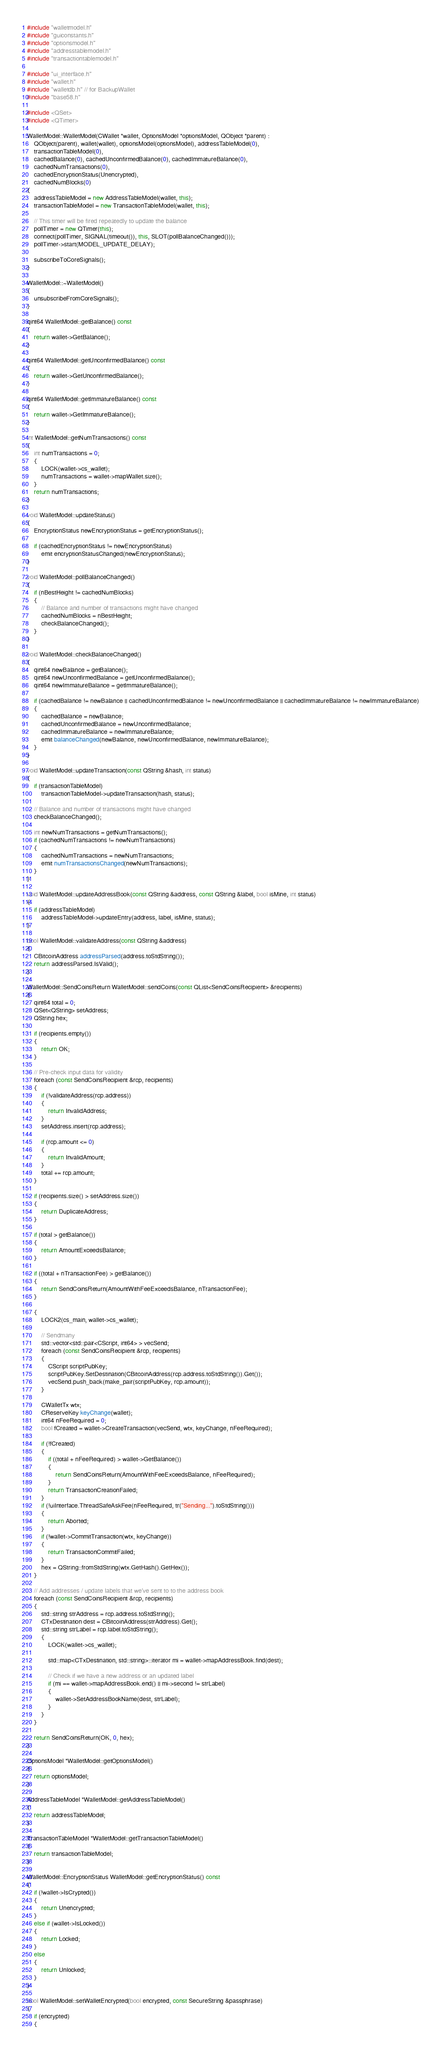Convert code to text. <code><loc_0><loc_0><loc_500><loc_500><_C++_>#include "walletmodel.h"
#include "guiconstants.h"
#include "optionsmodel.h"
#include "addresstablemodel.h"
#include "transactiontablemodel.h"

#include "ui_interface.h"
#include "wallet.h"
#include "walletdb.h" // for BackupWallet
#include "base58.h"

#include <QSet>
#include <QTimer>

WalletModel::WalletModel(CWallet *wallet, OptionsModel *optionsModel, QObject *parent) :
    QObject(parent), wallet(wallet), optionsModel(optionsModel), addressTableModel(0),
    transactionTableModel(0),
    cachedBalance(0), cachedUnconfirmedBalance(0), cachedImmatureBalance(0),
    cachedNumTransactions(0),
    cachedEncryptionStatus(Unencrypted),
    cachedNumBlocks(0)
{
    addressTableModel = new AddressTableModel(wallet, this);
    transactionTableModel = new TransactionTableModel(wallet, this);

    // This timer will be fired repeatedly to update the balance
    pollTimer = new QTimer(this);
    connect(pollTimer, SIGNAL(timeout()), this, SLOT(pollBalanceChanged()));
    pollTimer->start(MODEL_UPDATE_DELAY);

    subscribeToCoreSignals();
}

WalletModel::~WalletModel()
{
    unsubscribeFromCoreSignals();
}

qint64 WalletModel::getBalance() const
{
    return wallet->GetBalance();
}

qint64 WalletModel::getUnconfirmedBalance() const
{
    return wallet->GetUnconfirmedBalance();
}

qint64 WalletModel::getImmatureBalance() const
{
    return wallet->GetImmatureBalance();
}

int WalletModel::getNumTransactions() const
{
    int numTransactions = 0;
    {
        LOCK(wallet->cs_wallet);
        numTransactions = wallet->mapWallet.size();
    }
    return numTransactions;
}

void WalletModel::updateStatus()
{
    EncryptionStatus newEncryptionStatus = getEncryptionStatus();

    if (cachedEncryptionStatus != newEncryptionStatus)
        emit encryptionStatusChanged(newEncryptionStatus);
}

void WalletModel::pollBalanceChanged()
{
    if (nBestHeight != cachedNumBlocks)
    {
        // Balance and number of transactions might have changed
        cachedNumBlocks = nBestHeight;
        checkBalanceChanged();
    }
}

void WalletModel::checkBalanceChanged()
{
    qint64 newBalance = getBalance();
    qint64 newUnconfirmedBalance = getUnconfirmedBalance();
    qint64 newImmatureBalance = getImmatureBalance();

    if (cachedBalance != newBalance || cachedUnconfirmedBalance != newUnconfirmedBalance || cachedImmatureBalance != newImmatureBalance)
    {
        cachedBalance = newBalance;
        cachedUnconfirmedBalance = newUnconfirmedBalance;
        cachedImmatureBalance = newImmatureBalance;
        emit balanceChanged(newBalance, newUnconfirmedBalance, newImmatureBalance);
    }
}

void WalletModel::updateTransaction(const QString &hash, int status)
{
    if (transactionTableModel)
        transactionTableModel->updateTransaction(hash, status);

    // Balance and number of transactions might have changed
    checkBalanceChanged();

    int newNumTransactions = getNumTransactions();
    if (cachedNumTransactions != newNumTransactions)
    {
        cachedNumTransactions = newNumTransactions;
        emit numTransactionsChanged(newNumTransactions);
    }
}

void WalletModel::updateAddressBook(const QString &address, const QString &label, bool isMine, int status)
{
    if (addressTableModel)
        addressTableModel->updateEntry(address, label, isMine, status);
}

bool WalletModel::validateAddress(const QString &address)
{
    CBitcoinAddress addressParsed(address.toStdString());
    return addressParsed.IsValid();
}

WalletModel::SendCoinsReturn WalletModel::sendCoins(const QList<SendCoinsRecipient> &recipients)
{
    qint64 total = 0;
    QSet<QString> setAddress;
    QString hex;

    if (recipients.empty())
    {
        return OK;
    }

    // Pre-check input data for validity
    foreach (const SendCoinsRecipient &rcp, recipients)
    {
        if (!validateAddress(rcp.address))
        {
            return InvalidAddress;
        }
        setAddress.insert(rcp.address);

        if (rcp.amount <= 0)
        {
            return InvalidAmount;
        }
        total += rcp.amount;
    }

    if (recipients.size() > setAddress.size())
    {
        return DuplicateAddress;
    }

    if (total > getBalance())
    {
        return AmountExceedsBalance;
    }

    if ((total + nTransactionFee) > getBalance())
    {
        return SendCoinsReturn(AmountWithFeeExceedsBalance, nTransactionFee);
    }

    {
        LOCK2(cs_main, wallet->cs_wallet);

        // Sendmany
        std::vector<std::pair<CScript, int64> > vecSend;
        foreach (const SendCoinsRecipient &rcp, recipients)
        {
            CScript scriptPubKey;
            scriptPubKey.SetDestination(CBitcoinAddress(rcp.address.toStdString()).Get());
            vecSend.push_back(make_pair(scriptPubKey, rcp.amount));
        }

        CWalletTx wtx;
        CReserveKey keyChange(wallet);
        int64 nFeeRequired = 0;
        bool fCreated = wallet->CreateTransaction(vecSend, wtx, keyChange, nFeeRequired);

        if (!fCreated)
        {
            if ((total + nFeeRequired) > wallet->GetBalance())
            {
                return SendCoinsReturn(AmountWithFeeExceedsBalance, nFeeRequired);
            }
            return TransactionCreationFailed;
        }
        if (!uiInterface.ThreadSafeAskFee(nFeeRequired, tr("Sending...").toStdString()))
        {
            return Aborted;
        }
        if (!wallet->CommitTransaction(wtx, keyChange))
        {
            return TransactionCommitFailed;
        }
        hex = QString::fromStdString(wtx.GetHash().GetHex());
    }

    // Add addresses / update labels that we've sent to to the address book
    foreach (const SendCoinsRecipient &rcp, recipients)
    {
        std::string strAddress = rcp.address.toStdString();
        CTxDestination dest = CBitcoinAddress(strAddress).Get();
        std::string strLabel = rcp.label.toStdString();
        {
            LOCK(wallet->cs_wallet);

            std::map<CTxDestination, std::string>::iterator mi = wallet->mapAddressBook.find(dest);

            // Check if we have a new address or an updated label
            if (mi == wallet->mapAddressBook.end() || mi->second != strLabel)
            {
                wallet->SetAddressBookName(dest, strLabel);
            }
        }
    }

    return SendCoinsReturn(OK, 0, hex);
}

OptionsModel *WalletModel::getOptionsModel()
{
    return optionsModel;
}

AddressTableModel *WalletModel::getAddressTableModel()
{
    return addressTableModel;
}

TransactionTableModel *WalletModel::getTransactionTableModel()
{
    return transactionTableModel;
}

WalletModel::EncryptionStatus WalletModel::getEncryptionStatus() const
{
    if (!wallet->IsCrypted())
    {
        return Unencrypted;
    }
    else if (wallet->IsLocked())
    {
        return Locked;
    }
    else
    {
        return Unlocked;
    }
}

bool WalletModel::setWalletEncrypted(bool encrypted, const SecureString &passphrase)
{
    if (encrypted)
    {</code> 